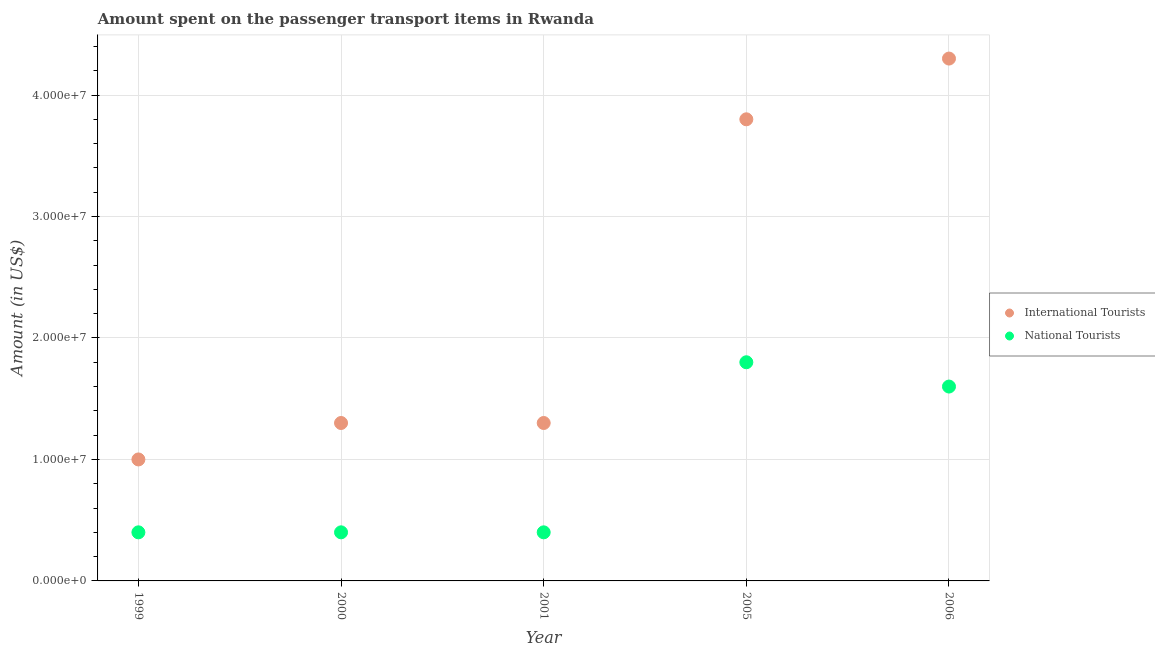What is the amount spent on transport items of national tourists in 2000?
Your response must be concise. 4.00e+06. Across all years, what is the maximum amount spent on transport items of national tourists?
Your response must be concise. 1.80e+07. Across all years, what is the minimum amount spent on transport items of national tourists?
Provide a succinct answer. 4.00e+06. What is the total amount spent on transport items of international tourists in the graph?
Offer a very short reply. 1.17e+08. What is the difference between the amount spent on transport items of international tourists in 1999 and that in 2005?
Keep it short and to the point. -2.80e+07. What is the difference between the amount spent on transport items of international tourists in 2001 and the amount spent on transport items of national tourists in 2005?
Keep it short and to the point. -5.00e+06. What is the average amount spent on transport items of international tourists per year?
Make the answer very short. 2.34e+07. In the year 2005, what is the difference between the amount spent on transport items of national tourists and amount spent on transport items of international tourists?
Keep it short and to the point. -2.00e+07. What is the ratio of the amount spent on transport items of national tourists in 2000 to that in 2005?
Offer a terse response. 0.22. What is the difference between the highest and the second highest amount spent on transport items of international tourists?
Offer a very short reply. 5.00e+06. What is the difference between the highest and the lowest amount spent on transport items of international tourists?
Offer a very short reply. 3.30e+07. In how many years, is the amount spent on transport items of international tourists greater than the average amount spent on transport items of international tourists taken over all years?
Offer a terse response. 2. What is the difference between two consecutive major ticks on the Y-axis?
Provide a short and direct response. 1.00e+07. Are the values on the major ticks of Y-axis written in scientific E-notation?
Offer a terse response. Yes. Does the graph contain any zero values?
Keep it short and to the point. No. Where does the legend appear in the graph?
Offer a terse response. Center right. How many legend labels are there?
Your answer should be very brief. 2. How are the legend labels stacked?
Give a very brief answer. Vertical. What is the title of the graph?
Keep it short and to the point. Amount spent on the passenger transport items in Rwanda. What is the label or title of the X-axis?
Offer a very short reply. Year. What is the label or title of the Y-axis?
Make the answer very short. Amount (in US$). What is the Amount (in US$) in International Tourists in 1999?
Your answer should be compact. 1.00e+07. What is the Amount (in US$) of National Tourists in 1999?
Provide a short and direct response. 4.00e+06. What is the Amount (in US$) in International Tourists in 2000?
Ensure brevity in your answer.  1.30e+07. What is the Amount (in US$) in International Tourists in 2001?
Ensure brevity in your answer.  1.30e+07. What is the Amount (in US$) of National Tourists in 2001?
Make the answer very short. 4.00e+06. What is the Amount (in US$) of International Tourists in 2005?
Give a very brief answer. 3.80e+07. What is the Amount (in US$) in National Tourists in 2005?
Make the answer very short. 1.80e+07. What is the Amount (in US$) in International Tourists in 2006?
Keep it short and to the point. 4.30e+07. What is the Amount (in US$) of National Tourists in 2006?
Provide a short and direct response. 1.60e+07. Across all years, what is the maximum Amount (in US$) of International Tourists?
Keep it short and to the point. 4.30e+07. Across all years, what is the maximum Amount (in US$) in National Tourists?
Offer a terse response. 1.80e+07. Across all years, what is the minimum Amount (in US$) in International Tourists?
Your answer should be very brief. 1.00e+07. Across all years, what is the minimum Amount (in US$) in National Tourists?
Provide a succinct answer. 4.00e+06. What is the total Amount (in US$) of International Tourists in the graph?
Your answer should be compact. 1.17e+08. What is the total Amount (in US$) in National Tourists in the graph?
Ensure brevity in your answer.  4.60e+07. What is the difference between the Amount (in US$) of International Tourists in 1999 and that in 2005?
Offer a very short reply. -2.80e+07. What is the difference between the Amount (in US$) in National Tourists in 1999 and that in 2005?
Ensure brevity in your answer.  -1.40e+07. What is the difference between the Amount (in US$) in International Tourists in 1999 and that in 2006?
Offer a terse response. -3.30e+07. What is the difference between the Amount (in US$) of National Tourists in 1999 and that in 2006?
Give a very brief answer. -1.20e+07. What is the difference between the Amount (in US$) of International Tourists in 2000 and that in 2001?
Make the answer very short. 0. What is the difference between the Amount (in US$) in International Tourists in 2000 and that in 2005?
Your response must be concise. -2.50e+07. What is the difference between the Amount (in US$) in National Tourists in 2000 and that in 2005?
Give a very brief answer. -1.40e+07. What is the difference between the Amount (in US$) of International Tourists in 2000 and that in 2006?
Your response must be concise. -3.00e+07. What is the difference between the Amount (in US$) of National Tourists in 2000 and that in 2006?
Give a very brief answer. -1.20e+07. What is the difference between the Amount (in US$) of International Tourists in 2001 and that in 2005?
Your answer should be very brief. -2.50e+07. What is the difference between the Amount (in US$) of National Tourists in 2001 and that in 2005?
Offer a terse response. -1.40e+07. What is the difference between the Amount (in US$) in International Tourists in 2001 and that in 2006?
Provide a succinct answer. -3.00e+07. What is the difference between the Amount (in US$) in National Tourists in 2001 and that in 2006?
Provide a short and direct response. -1.20e+07. What is the difference between the Amount (in US$) in International Tourists in 2005 and that in 2006?
Offer a terse response. -5.00e+06. What is the difference between the Amount (in US$) of International Tourists in 1999 and the Amount (in US$) of National Tourists in 2001?
Make the answer very short. 6.00e+06. What is the difference between the Amount (in US$) of International Tourists in 1999 and the Amount (in US$) of National Tourists in 2005?
Your response must be concise. -8.00e+06. What is the difference between the Amount (in US$) of International Tourists in 1999 and the Amount (in US$) of National Tourists in 2006?
Keep it short and to the point. -6.00e+06. What is the difference between the Amount (in US$) in International Tourists in 2000 and the Amount (in US$) in National Tourists in 2001?
Offer a terse response. 9.00e+06. What is the difference between the Amount (in US$) of International Tourists in 2000 and the Amount (in US$) of National Tourists in 2005?
Give a very brief answer. -5.00e+06. What is the difference between the Amount (in US$) of International Tourists in 2000 and the Amount (in US$) of National Tourists in 2006?
Keep it short and to the point. -3.00e+06. What is the difference between the Amount (in US$) in International Tourists in 2001 and the Amount (in US$) in National Tourists in 2005?
Provide a short and direct response. -5.00e+06. What is the difference between the Amount (in US$) in International Tourists in 2001 and the Amount (in US$) in National Tourists in 2006?
Make the answer very short. -3.00e+06. What is the difference between the Amount (in US$) of International Tourists in 2005 and the Amount (in US$) of National Tourists in 2006?
Offer a very short reply. 2.20e+07. What is the average Amount (in US$) in International Tourists per year?
Provide a succinct answer. 2.34e+07. What is the average Amount (in US$) of National Tourists per year?
Offer a terse response. 9.20e+06. In the year 1999, what is the difference between the Amount (in US$) in International Tourists and Amount (in US$) in National Tourists?
Offer a terse response. 6.00e+06. In the year 2000, what is the difference between the Amount (in US$) of International Tourists and Amount (in US$) of National Tourists?
Provide a short and direct response. 9.00e+06. In the year 2001, what is the difference between the Amount (in US$) in International Tourists and Amount (in US$) in National Tourists?
Make the answer very short. 9.00e+06. In the year 2005, what is the difference between the Amount (in US$) of International Tourists and Amount (in US$) of National Tourists?
Keep it short and to the point. 2.00e+07. In the year 2006, what is the difference between the Amount (in US$) of International Tourists and Amount (in US$) of National Tourists?
Your answer should be very brief. 2.70e+07. What is the ratio of the Amount (in US$) in International Tourists in 1999 to that in 2000?
Provide a short and direct response. 0.77. What is the ratio of the Amount (in US$) of National Tourists in 1999 to that in 2000?
Your response must be concise. 1. What is the ratio of the Amount (in US$) of International Tourists in 1999 to that in 2001?
Ensure brevity in your answer.  0.77. What is the ratio of the Amount (in US$) of International Tourists in 1999 to that in 2005?
Your response must be concise. 0.26. What is the ratio of the Amount (in US$) in National Tourists in 1999 to that in 2005?
Ensure brevity in your answer.  0.22. What is the ratio of the Amount (in US$) in International Tourists in 1999 to that in 2006?
Your answer should be very brief. 0.23. What is the ratio of the Amount (in US$) of International Tourists in 2000 to that in 2005?
Give a very brief answer. 0.34. What is the ratio of the Amount (in US$) in National Tourists in 2000 to that in 2005?
Provide a short and direct response. 0.22. What is the ratio of the Amount (in US$) in International Tourists in 2000 to that in 2006?
Provide a short and direct response. 0.3. What is the ratio of the Amount (in US$) in National Tourists in 2000 to that in 2006?
Make the answer very short. 0.25. What is the ratio of the Amount (in US$) of International Tourists in 2001 to that in 2005?
Offer a terse response. 0.34. What is the ratio of the Amount (in US$) of National Tourists in 2001 to that in 2005?
Your response must be concise. 0.22. What is the ratio of the Amount (in US$) of International Tourists in 2001 to that in 2006?
Offer a terse response. 0.3. What is the ratio of the Amount (in US$) in National Tourists in 2001 to that in 2006?
Ensure brevity in your answer.  0.25. What is the ratio of the Amount (in US$) of International Tourists in 2005 to that in 2006?
Keep it short and to the point. 0.88. What is the ratio of the Amount (in US$) of National Tourists in 2005 to that in 2006?
Offer a very short reply. 1.12. What is the difference between the highest and the second highest Amount (in US$) in International Tourists?
Your answer should be very brief. 5.00e+06. What is the difference between the highest and the second highest Amount (in US$) in National Tourists?
Your answer should be very brief. 2.00e+06. What is the difference between the highest and the lowest Amount (in US$) of International Tourists?
Keep it short and to the point. 3.30e+07. What is the difference between the highest and the lowest Amount (in US$) in National Tourists?
Provide a succinct answer. 1.40e+07. 